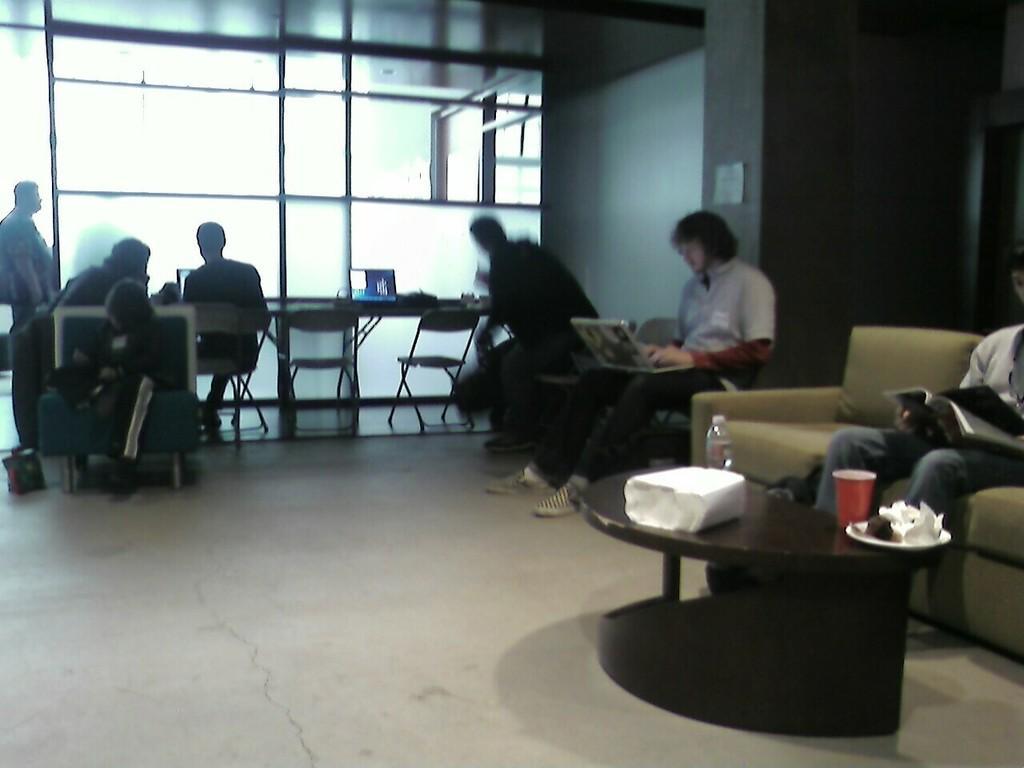Can you describe this image briefly? In this image there are a group of people who are sitting, and on the right side there is a couch. On the couch there is one person who is sitting and reading books, in front of him there is one table. On the table there are some plates, cups, bottles and one box and in the center there is a glass door and a wall. At the bottom there is a walkway. 